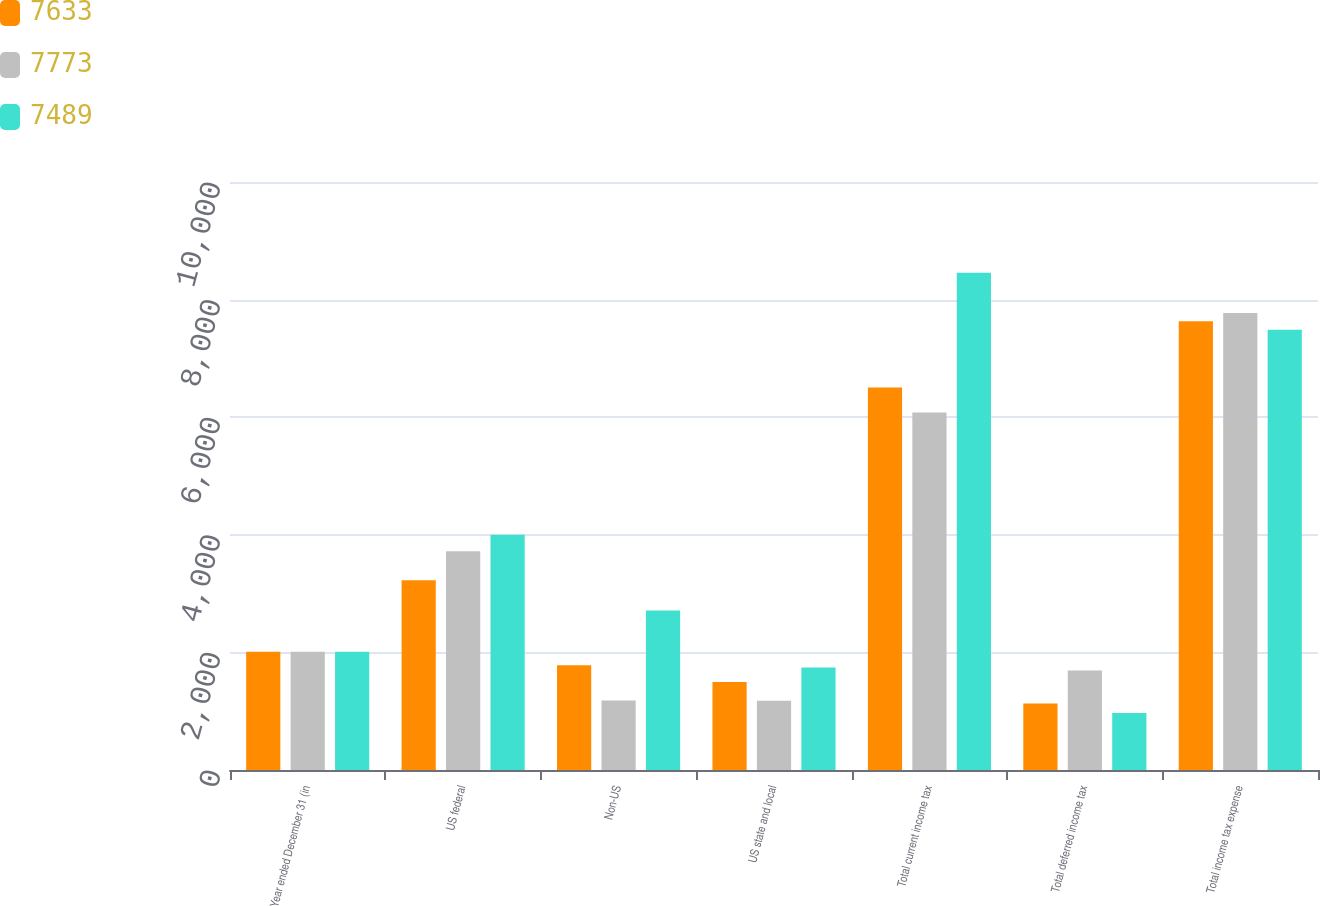Convert chart to OTSL. <chart><loc_0><loc_0><loc_500><loc_500><stacked_bar_chart><ecel><fcel>Year ended December 31 (in<fcel>US federal<fcel>Non-US<fcel>US state and local<fcel>Total current income tax<fcel>Total deferred income tax<fcel>Total income tax expense<nl><fcel>7633<fcel>2012<fcel>3225<fcel>1782<fcel>1496<fcel>6503<fcel>1130<fcel>7633<nl><fcel>7773<fcel>2011<fcel>3719<fcel>1183<fcel>1178<fcel>6080<fcel>1693<fcel>7773<nl><fcel>7489<fcel>2010<fcel>4001<fcel>2712<fcel>1744<fcel>8457<fcel>968<fcel>7489<nl></chart> 